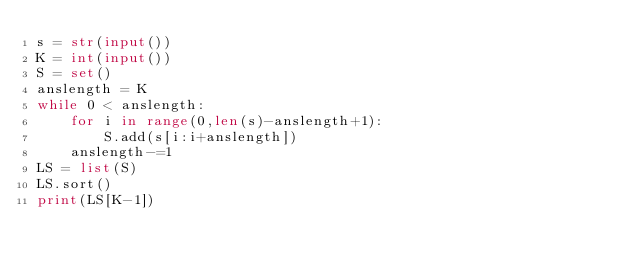<code> <loc_0><loc_0><loc_500><loc_500><_Python_>s = str(input())
K = int(input())
S = set()
anslength = K
while 0 < anslength:
    for i in range(0,len(s)-anslength+1):
        S.add(s[i:i+anslength])
    anslength-=1
LS = list(S)
LS.sort()
print(LS[K-1])</code> 